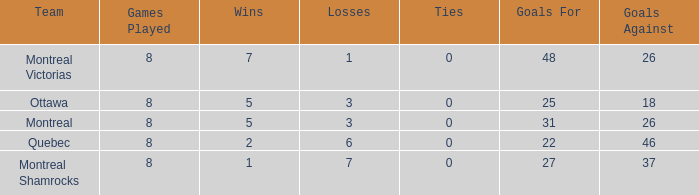For teams with 7 victories, what is the quantity of goals against? 26.0. 